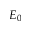Convert formula to latex. <formula><loc_0><loc_0><loc_500><loc_500>E _ { 0 }</formula> 